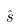<formula> <loc_0><loc_0><loc_500><loc_500>\hat { s }</formula> 